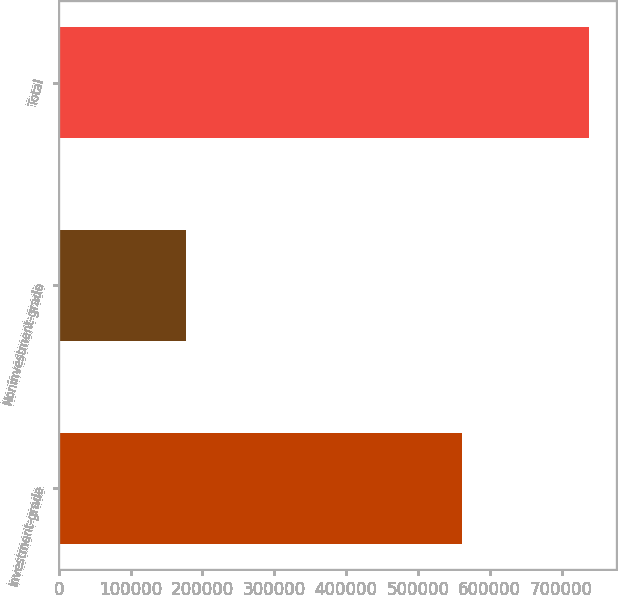<chart> <loc_0><loc_0><loc_500><loc_500><bar_chart><fcel>Investment-grade<fcel>Noninvestment-grade<fcel>Total<nl><fcel>561379<fcel>177085<fcel>738464<nl></chart> 